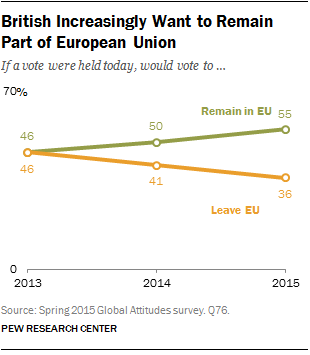Mention a couple of crucial points in this snapshot. The largest value of the green line is 55. The total value of the highest green line and the lowest orange line is 91. 